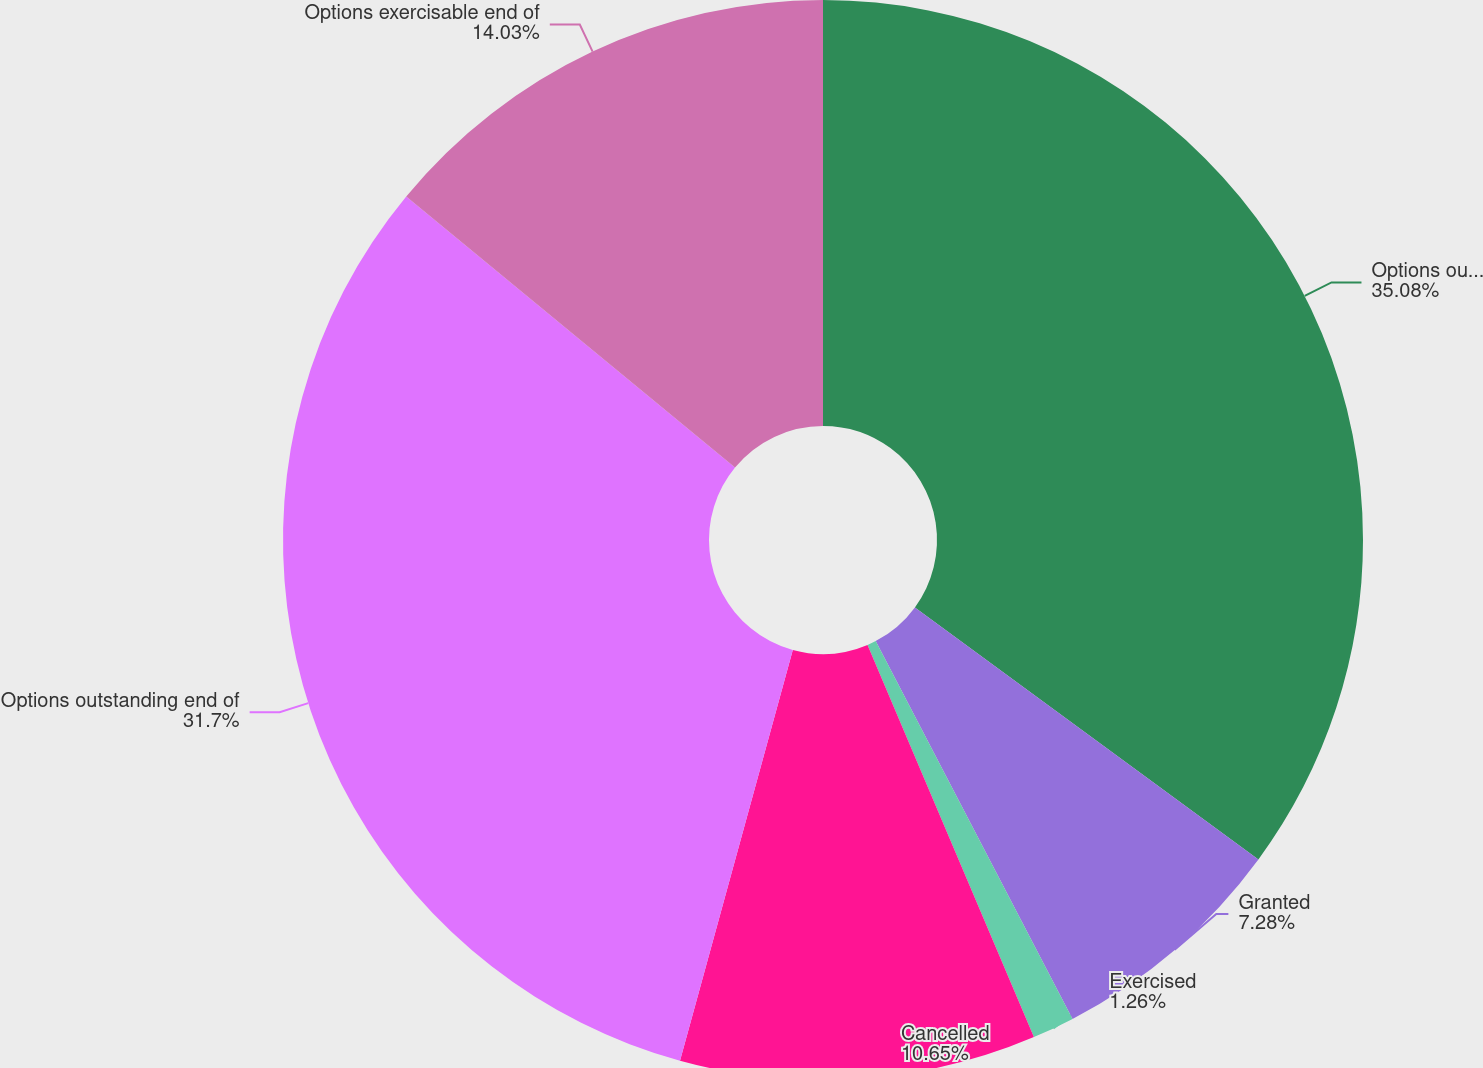Convert chart to OTSL. <chart><loc_0><loc_0><loc_500><loc_500><pie_chart><fcel>Options outstanding beginning<fcel>Granted<fcel>Exercised<fcel>Cancelled<fcel>Options outstanding end of<fcel>Options exercisable end of<nl><fcel>35.07%<fcel>7.28%<fcel>1.26%<fcel>10.65%<fcel>31.7%<fcel>14.03%<nl></chart> 